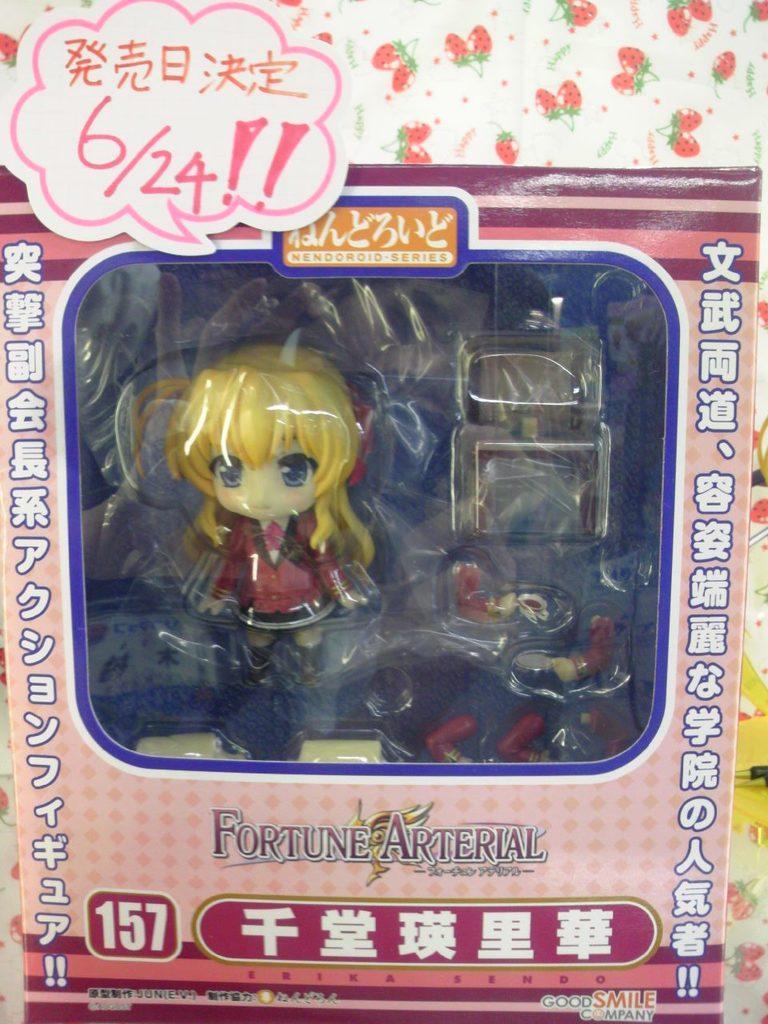Can you describe this image briefly? In this image we can see a toy placed in the carton. In the background there is a wall and we can see text. 